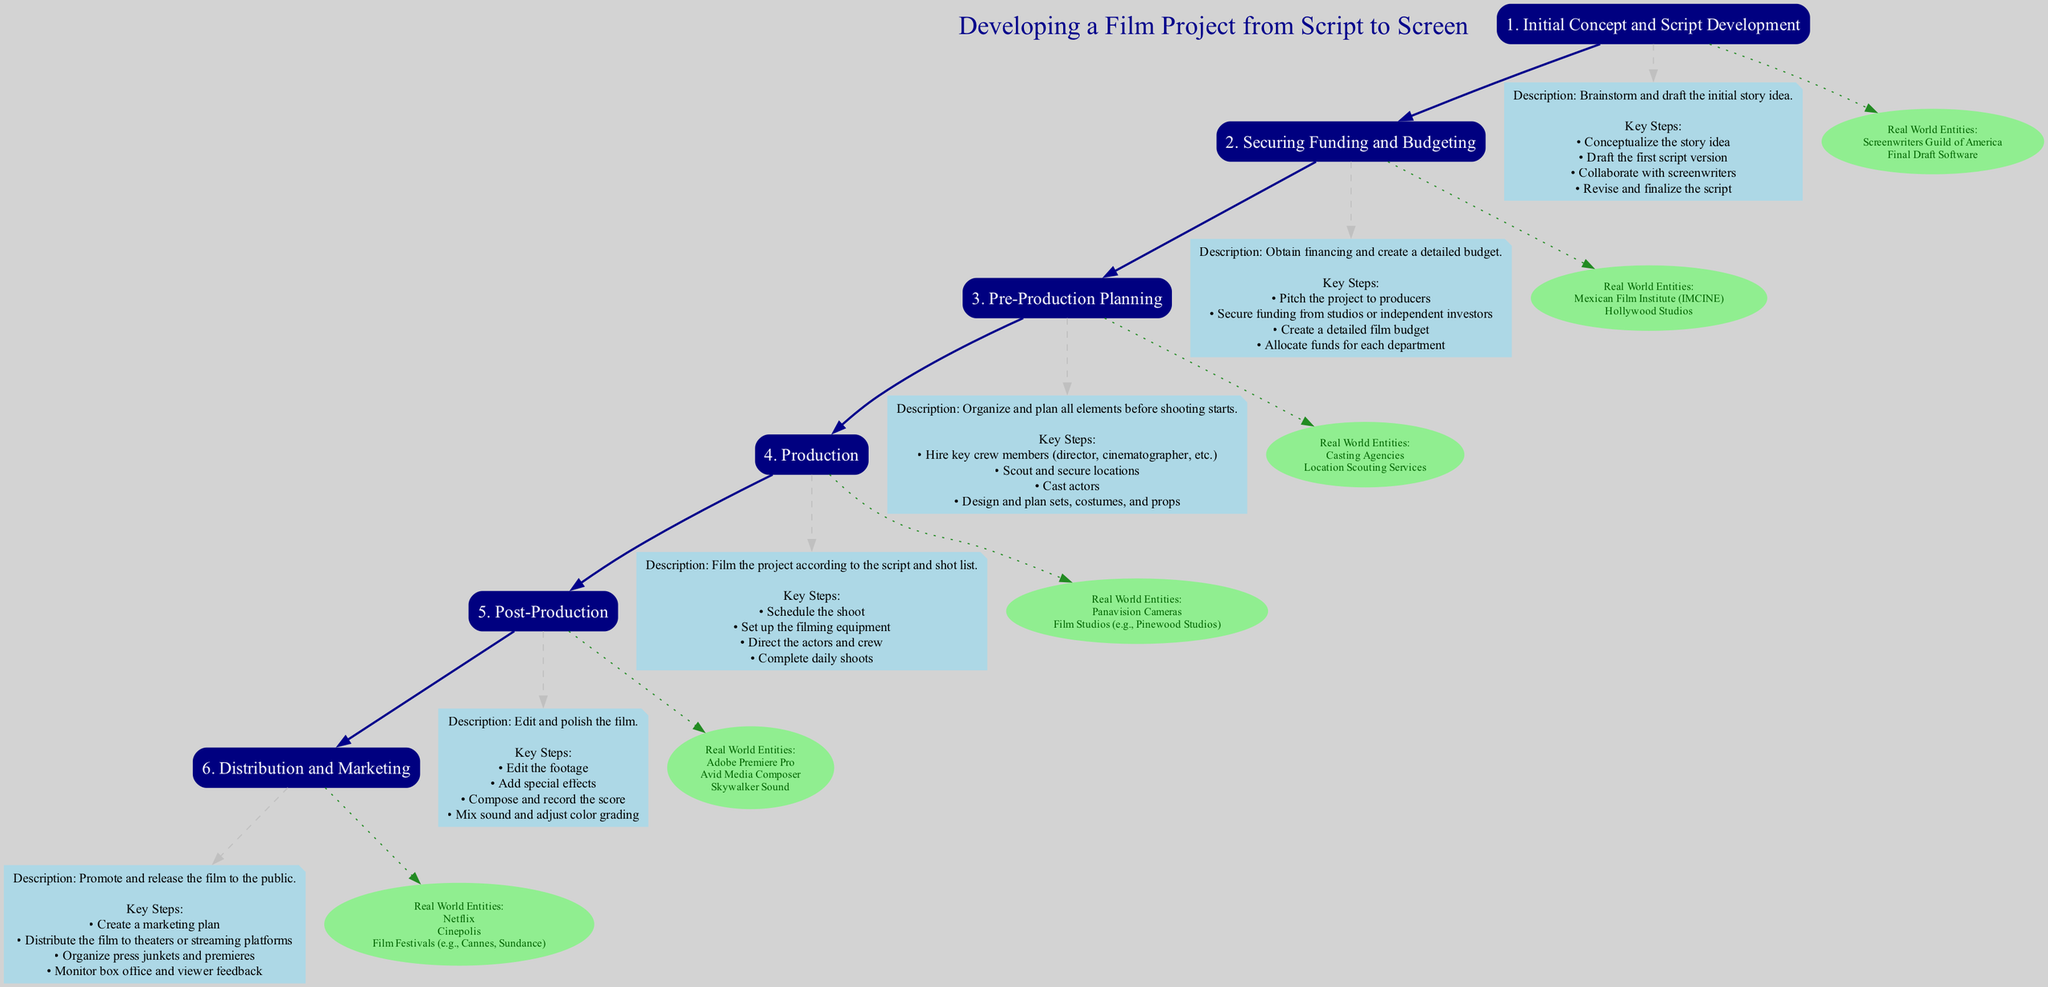What is the first step in the film project development process? The flowchart indicates that the first step is "Initial Concept and Script Development." This is the first node listed in the sequence of steps.
Answer: Initial Concept and Script Development How many key steps are outlined in the "Post-Production" section? The diagram shows that the "Post-Production" section has four key steps listed beneath it. You can count the number of bullets under that section.
Answer: 4 What does the "Securing Funding and Budgeting" step involve? This step encompasses obtaining financing and creating a detailed budget. It is the description associated with the node for Securing Funding and Budgeting.
Answer: Obtain financing and create a detailed budget What is the relationship between "Pre-Production Planning" and "Production"? The edge connecting these two nodes shows a direct transition from "Pre-Production Planning" to "Production," indicating that production begins after pre-production is completed.
Answer: Direct transition Which software is mentioned as a real-world entity in the "Post-Production" step? The diagram lists "Adobe Premiere Pro" as one of the real-world entities associated with the "Post-Production" step, specifically under the corresponding node.
Answer: Adobe Premiere Pro What is the final step in the film project development process? According to the diagram, the last step is "Distribution and Marketing," which is the sixth and final node in the sequence of steps.
Answer: Distribution and Marketing How many different steps are outlined in the film project development process? The diagram outlines a total of six distinct steps from the initial concept to distribution and marketing, as indicated by the nodes created for each step.
Answer: 6 What type of entity is "Final Draft Software" classified as in the diagram? "Final Draft Software" is categorized as a real-world entity associated with the "Initial Concept and Script Development" step, indicated by the corresponding note connected to it.
Answer: Real World Entity Which step comes after "Production" in the process? The flowchart indicates that "Post-Production" follows "Production," as per the flow of the diagram, creating a sequence in film project development.
Answer: Post-Production 